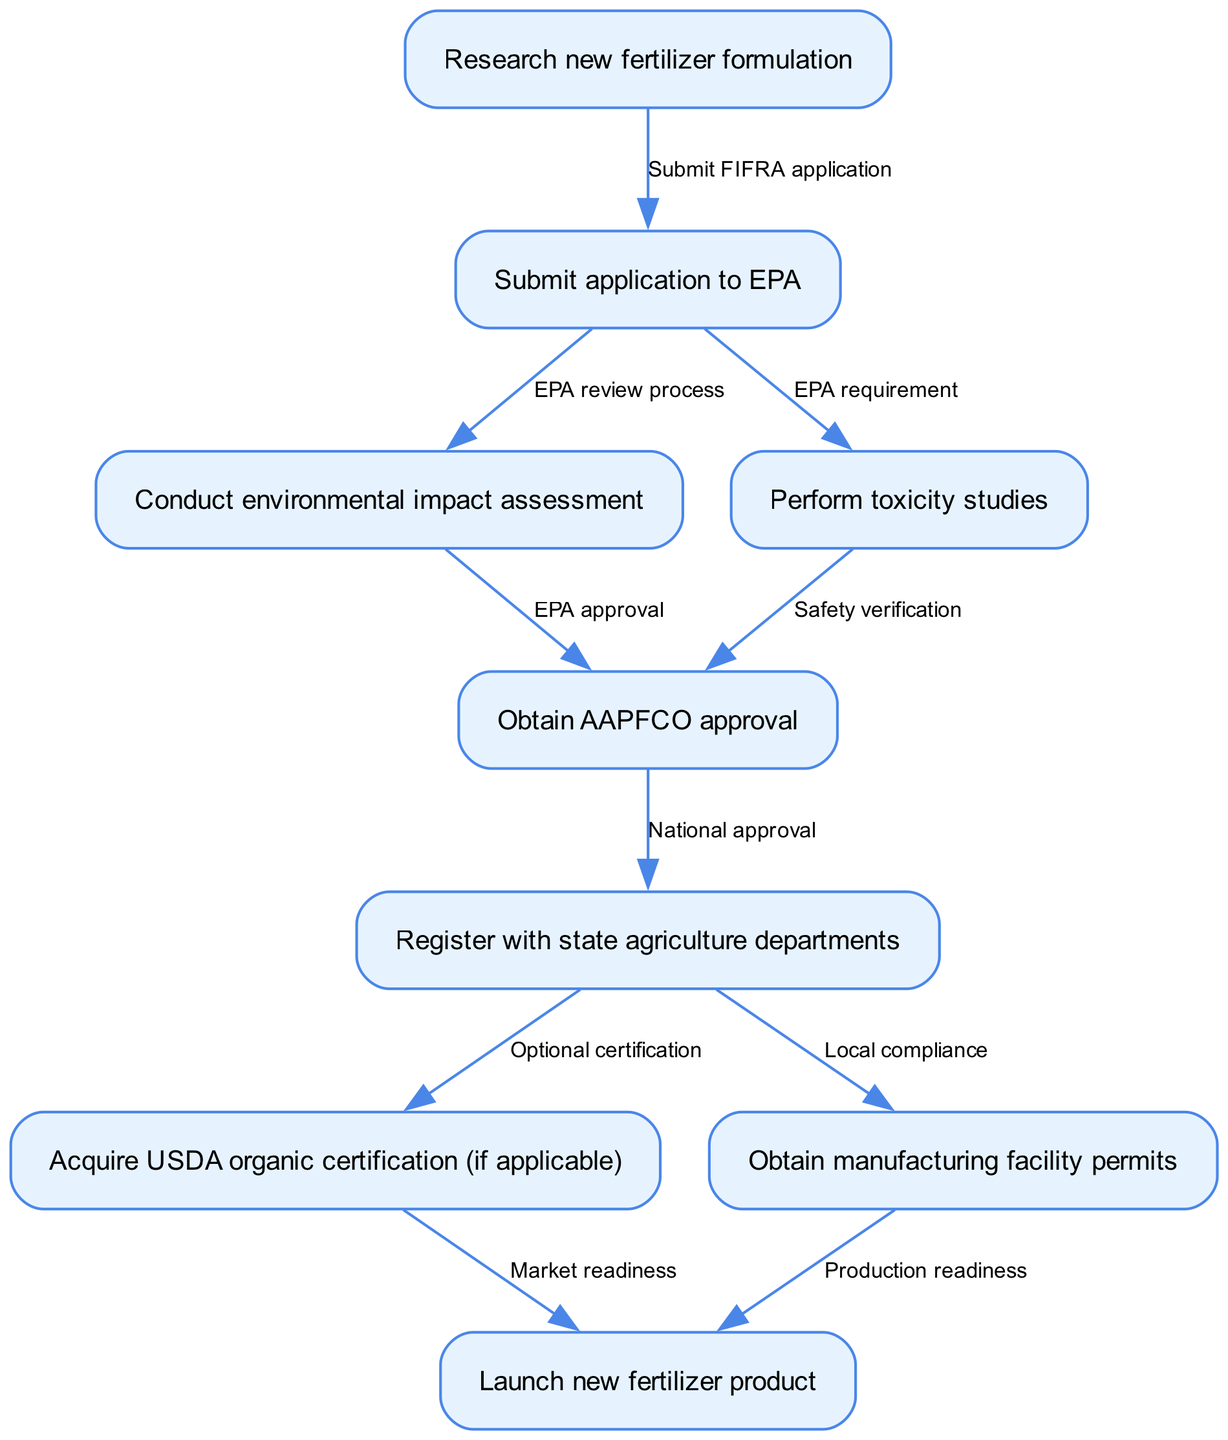What is the first step in the regulatory compliance pathway? The first step is represented by the node labeled "Research new fertilizer formulation". It initiates the process of obtaining the necessary permits and certifications for new fertilizer formulations.
Answer: Research new fertilizer formulation How many nodes are present in the diagram? The diagram has a total of nine nodes that represent distinct steps in the regulatory compliance pathway. Counting these nodes gives the answer.
Answer: 9 What does the node "Obtain AAPFCO approval" depend on? This node depends on two previous nodes: "Conduct environmental impact assessment" and "Perform toxicity studies". Both are required before obtaining AAPFCO approval.
Answer: Conduct environmental impact assessment, Perform toxicity studies Which step comes after "Submit application to EPA"? Following "Submit application to EPA", the next step is "Conduct environmental impact assessment", which is portrayed in the diagram as directly connected to the application submission.
Answer: Conduct environmental impact assessment What certification may be acquired after registering with state agriculture departments? After registering with state agriculture departments, one may acquire "USDA organic certification", which is noted as an optional step in the regulatory pathway.
Answer: USDA organic certification What is required before launching the new fertilizer product? Before launching the new fertilizer product, both "Acquire USDA organic certification (if applicable)" and "Obtain manufacturing facility permits" must be completed, as shown by the connections leading to the final launch.
Answer: Acquire USDA organic certification, Obtain manufacturing facility permits Which edge indicates a safety verification process? The edge labeled "Safety verification" connects the "Perform toxicity studies" node to "Obtain AAPFCO approval". This indicates that safety verification through toxicity studies is integral to this step.
Answer: Safety verification How many edges are there in the diagram? The diagram contains a total of nine edges, which connect the nodes and illustrate the flow from one step in the regulatory process to another.
Answer: 9 What does "EPA review process" indicate in the pathway? The "EPA review process" edge signifies the evaluation done by the Environmental Protection Agency after submitting the application, making it a critical aspect of regulatory compliance.
Answer: EPA review process What step involves "Local compliance"? The step that involves "Local compliance" is represented by the node "Register with state agriculture departments", which connects to this compliance requirement before proceeding to obtain the necessary permits.
Answer: Register with state agriculture departments 